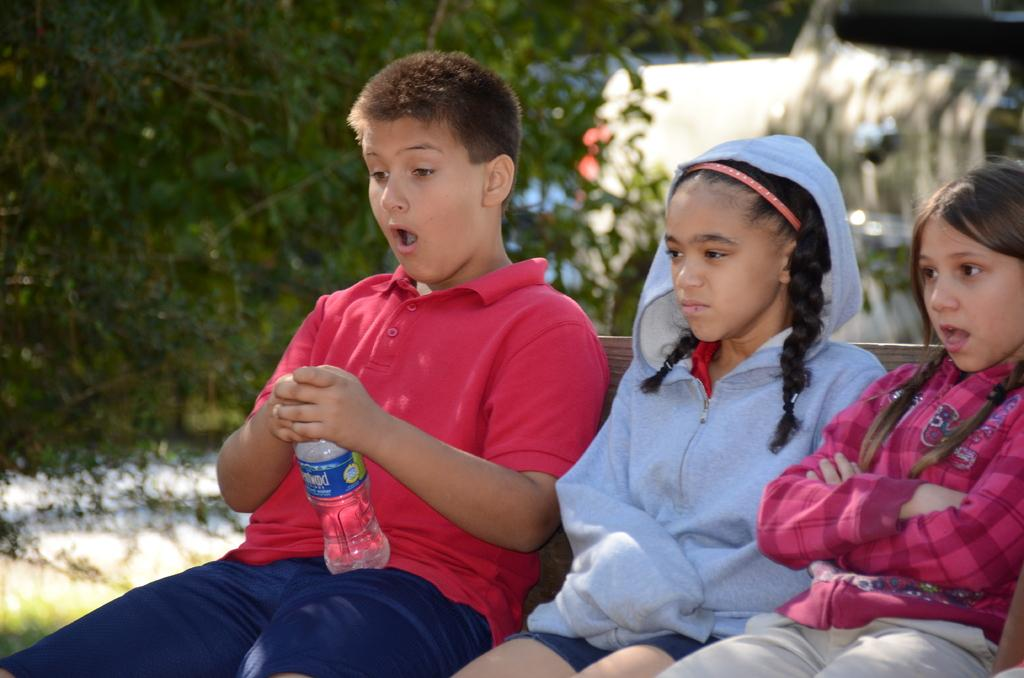How many children are present in the image? There are three children in the image. What are the children doing in the image? The children are sitting on a bench. Can you describe what one of the children is holding? One of the children is holding a water bottle. How many girls are in the image? Two of the children are girls. What can be seen in the background of the image? There are trees in the background of the image. What type of expansion is being discussed by the children in the image? There is no discussion of expansion in the image; the children are sitting on a bench and one is holding a water bottle. Can you tell me which brother is sitting next to the girl with the water bottle? There is no mention of a brother in the image; only three children are present, and two of them are girls. 